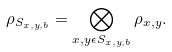Convert formula to latex. <formula><loc_0><loc_0><loc_500><loc_500>\rho _ { S _ { x , y , b } } = \bigotimes _ { x , y \epsilon S _ { x , y , b } } \rho _ { x , y } .</formula> 